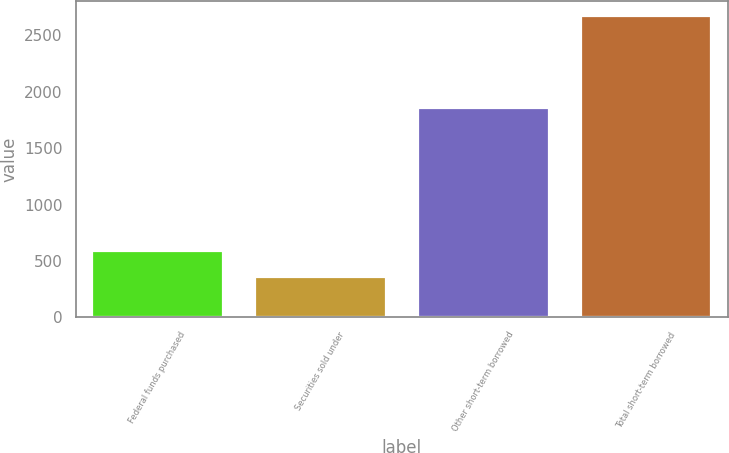Convert chart to OTSL. <chart><loc_0><loc_0><loc_500><loc_500><bar_chart><fcel>Federal funds purchased<fcel>Securities sold under<fcel>Other short-term borrowed<fcel>Total short-term borrowed<nl><fcel>586.6<fcel>355<fcel>1856<fcel>2671<nl></chart> 